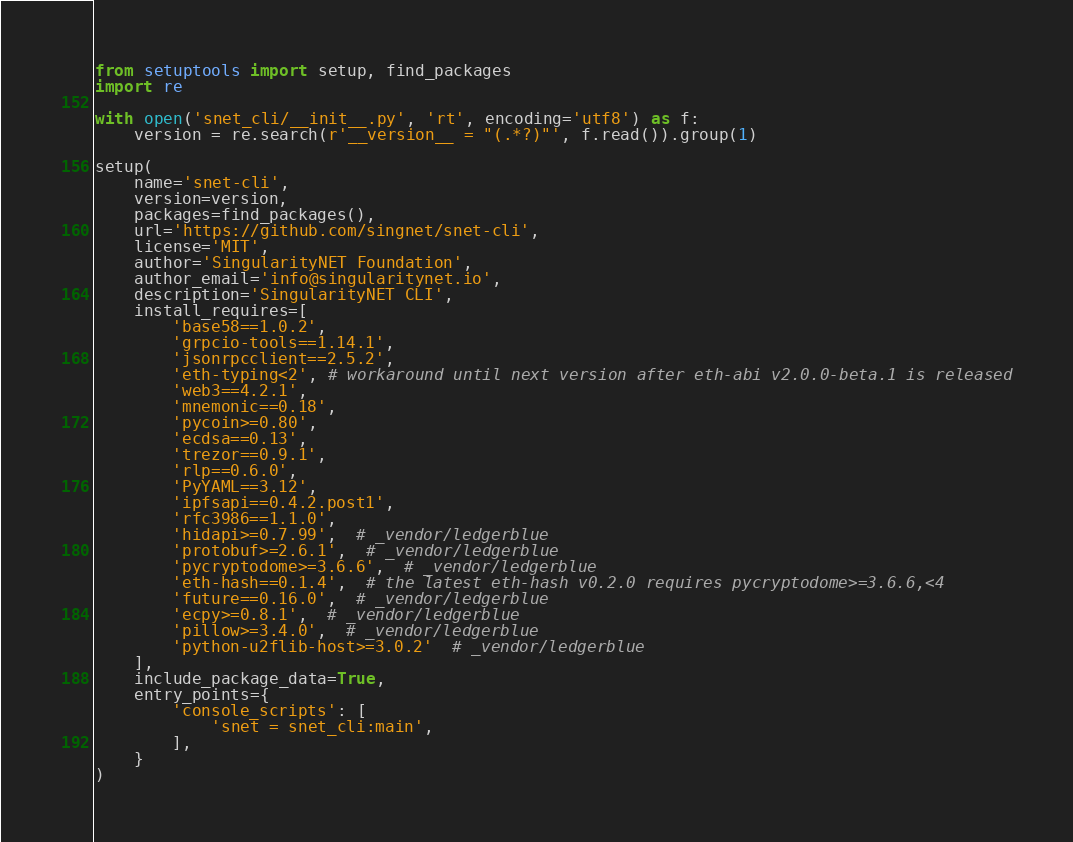Convert code to text. <code><loc_0><loc_0><loc_500><loc_500><_Python_>from setuptools import setup, find_packages
import re

with open('snet_cli/__init__.py', 'rt', encoding='utf8') as f:
    version = re.search(r'__version__ = "(.*?)"', f.read()).group(1)

setup(
    name='snet-cli',
    version=version,
    packages=find_packages(),
    url='https://github.com/singnet/snet-cli',
    license='MIT',
    author='SingularityNET Foundation',
    author_email='info@singularitynet.io',
    description='SingularityNET CLI',
    install_requires=[
        'base58==1.0.2',
        'grpcio-tools==1.14.1',
        'jsonrpcclient==2.5.2',
        'eth-typing<2', # workaround until next version after eth-abi v2.0.0-beta.1 is released
        'web3==4.2.1',
        'mnemonic==0.18',
        'pycoin>=0.80',
        'ecdsa==0.13',
        'trezor==0.9.1',
        'rlp==0.6.0',
        'PyYAML==3.12',
        'ipfsapi==0.4.2.post1',
        'rfc3986==1.1.0',
        'hidapi>=0.7.99',  # _vendor/ledgerblue
        'protobuf>=2.6.1',  # _vendor/ledgerblue
        'pycryptodome>=3.6.6',  # _vendor/ledgerblue
        'eth-hash==0.1.4',  # the latest eth-hash v0.2.0 requires pycryptodome>=3.6.6,<4
        'future==0.16.0',  # _vendor/ledgerblue
        'ecpy>=0.8.1',  # _vendor/ledgerblue
        'pillow>=3.4.0',  # _vendor/ledgerblue
        'python-u2flib-host>=3.0.2'  # _vendor/ledgerblue
    ],
    include_package_data=True,
    entry_points={
        'console_scripts': [
            'snet = snet_cli:main',
        ],
    }
)
</code> 